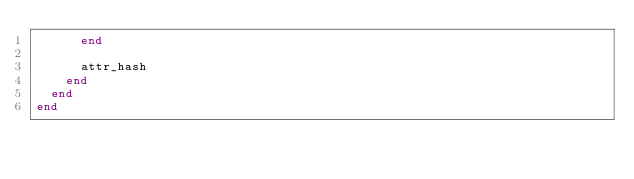<code> <loc_0><loc_0><loc_500><loc_500><_Ruby_>      end

      attr_hash
    end
  end
end
</code> 